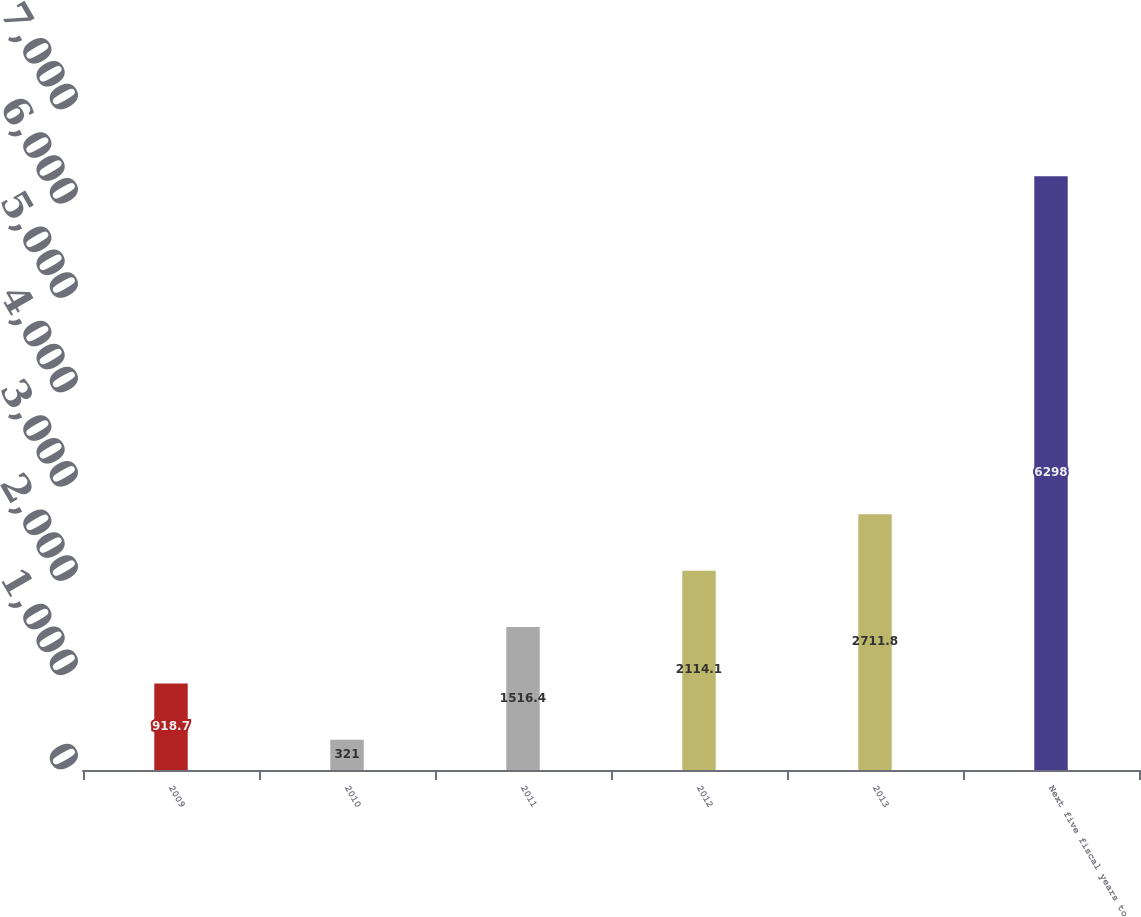Convert chart to OTSL. <chart><loc_0><loc_0><loc_500><loc_500><bar_chart><fcel>2009<fcel>2010<fcel>2011<fcel>2012<fcel>2013<fcel>Next five fiscal years to<nl><fcel>918.7<fcel>321<fcel>1516.4<fcel>2114.1<fcel>2711.8<fcel>6298<nl></chart> 